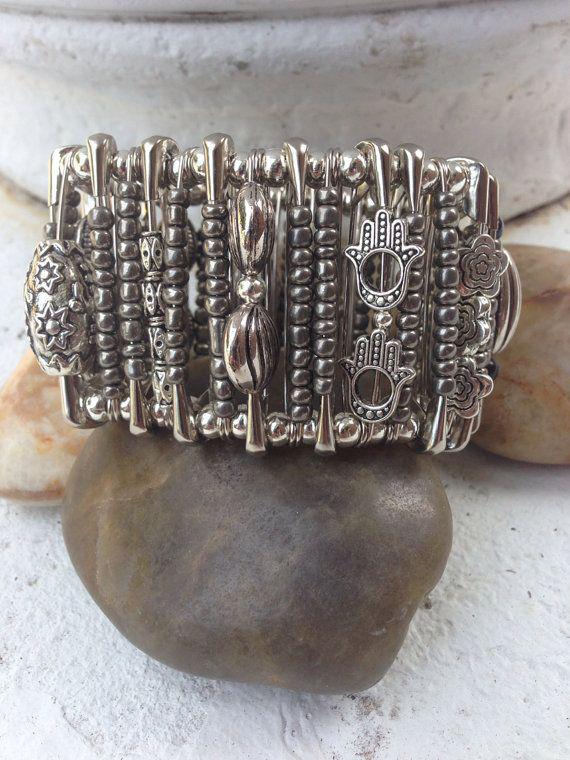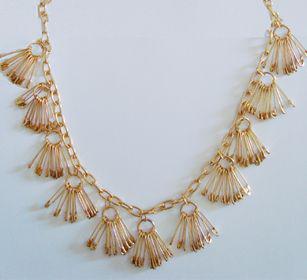The first image is the image on the left, the second image is the image on the right. Evaluate the accuracy of this statement regarding the images: "An image features a necklace strung with only gold safety pins.". Is it true? Answer yes or no. Yes. The first image is the image on the left, the second image is the image on the right. Examine the images to the left and right. Is the description "The jewelry in the right photo is not made with any silver colored safety pins." accurate? Answer yes or no. Yes. 